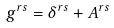Convert formula to latex. <formula><loc_0><loc_0><loc_500><loc_500>g ^ { r s } = \delta ^ { r s } + A ^ { r s }</formula> 